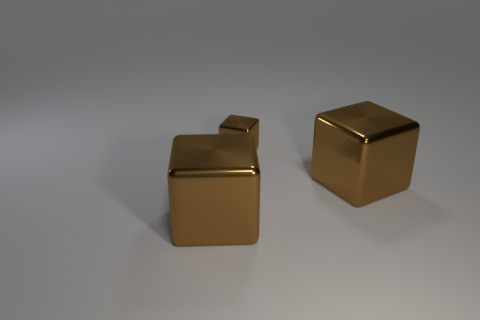Subtract all big brown cubes. How many cubes are left? 1 Add 3 tiny brown blocks. How many objects exist? 6 Subtract all green blocks. Subtract all yellow cylinders. How many blocks are left? 3 Subtract all gray objects. Subtract all large cubes. How many objects are left? 1 Add 3 big metallic things. How many big metallic things are left? 5 Add 3 small brown objects. How many small brown objects exist? 4 Subtract 0 blue cylinders. How many objects are left? 3 